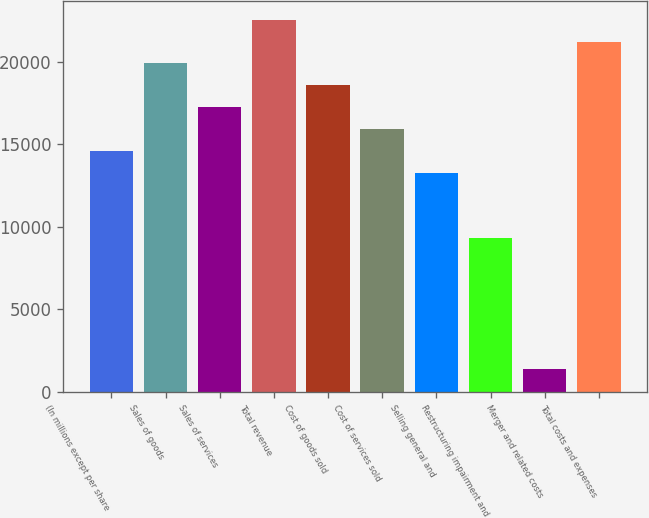Convert chart. <chart><loc_0><loc_0><loc_500><loc_500><bar_chart><fcel>(In millions except per share<fcel>Sales of goods<fcel>Sales of services<fcel>Total revenue<fcel>Cost of goods sold<fcel>Cost of services sold<fcel>Selling general and<fcel>Restructuring impairment and<fcel>Merger and related costs<fcel>Total costs and expenses<nl><fcel>14593.2<fcel>19890<fcel>17241.6<fcel>22538.4<fcel>18565.8<fcel>15917.4<fcel>13269<fcel>9296.4<fcel>1351.2<fcel>21214.2<nl></chart> 